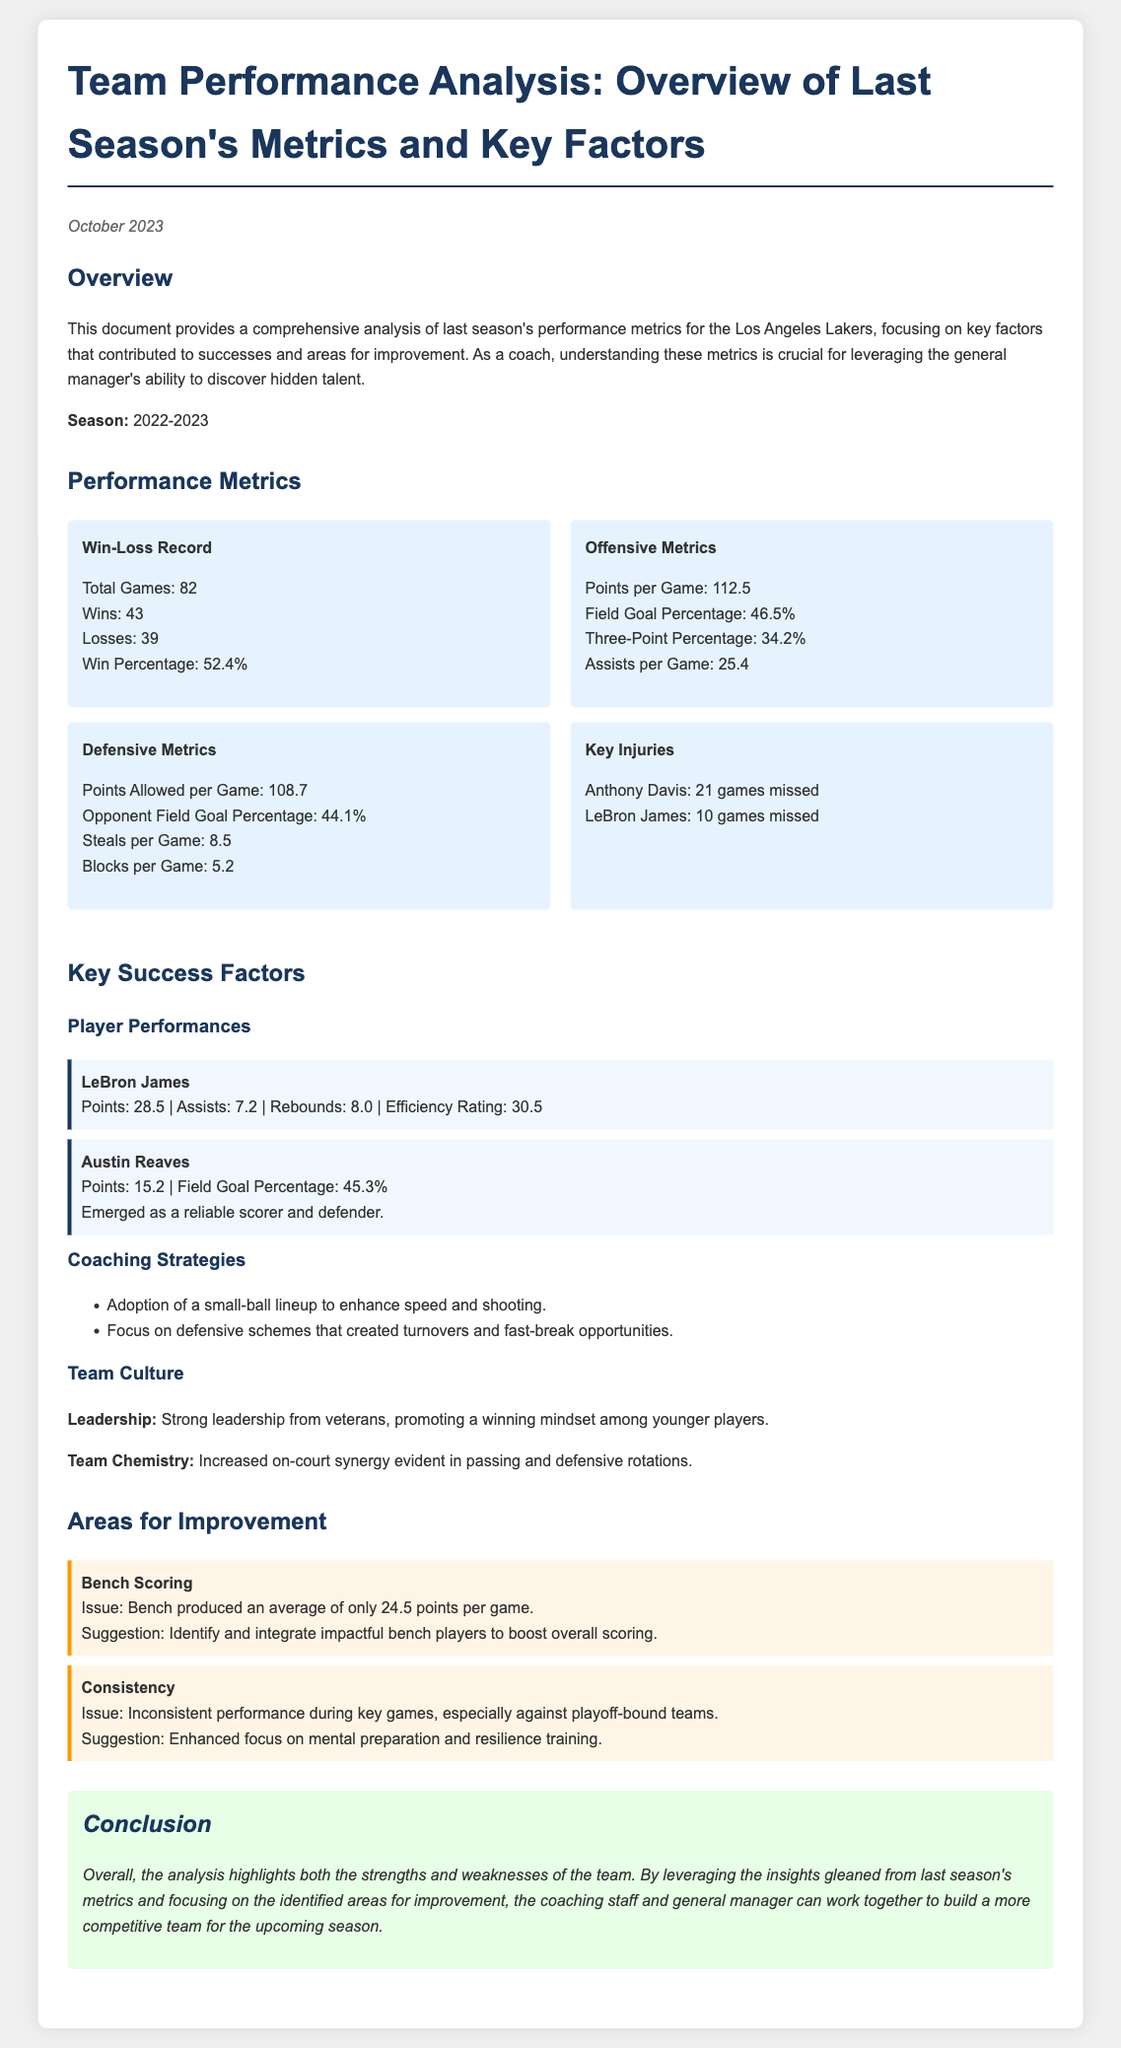What was the team's win percentage for the season? The win percentage is calculated as Wins divided by Total Games, which is 43 wins out of 82 games.
Answer: 52.4% How many total games did the team play? The document states the total number of games played during the season as 82.
Answer: 82 Who missed the most games due to injury? The document lists player Anthony Davis with 21 games missed as having the highest number of missed games.
Answer: Anthony Davis What was LeBron James' points per game? According to the key player performance metrics, LeBron James scored an average of 28.5 points per game.
Answer: 28.5 What issue is identified with bench scoring? The document highlights that the bench produced only an average of 24.5 points per game as a significant issue.
Answer: 24.5 points per game What is one suggested area for improvement? The document suggests that enhancing focus on mental preparation and resilience training is one area for improvement.
Answer: Mental preparation How did team chemistry impact performance? The document states that increased on-court synergy was evident in passing and defensive rotations, showcasing the impact of team chemistry.
Answer: Increased on-court synergy What was the points allowed per game by the team? The defensive metrics indicate that the team allowed an average of 108.7 points per game.
Answer: 108.7 What coaching strategy was adopted to enhance speed? The document mentions the adoption of a small-ball lineup as a strategy to enhance speed and shooting.
Answer: Small-ball lineup 